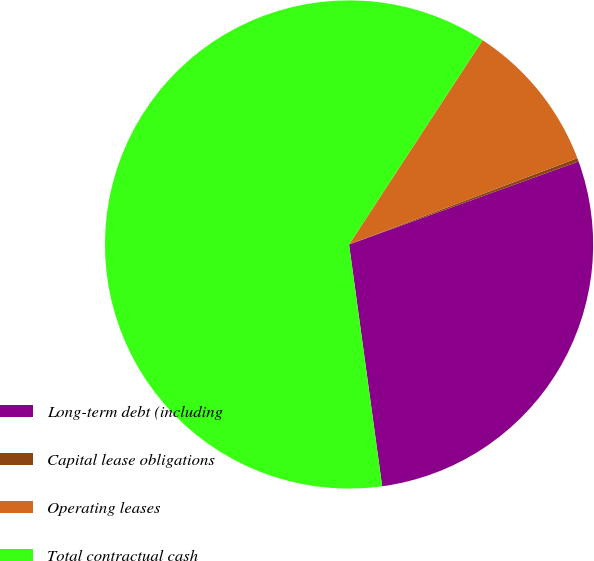Convert chart. <chart><loc_0><loc_0><loc_500><loc_500><pie_chart><fcel>Long-term debt (including<fcel>Capital lease obligations<fcel>Operating leases<fcel>Total contractual cash<nl><fcel>28.36%<fcel>0.23%<fcel>10.03%<fcel>61.38%<nl></chart> 